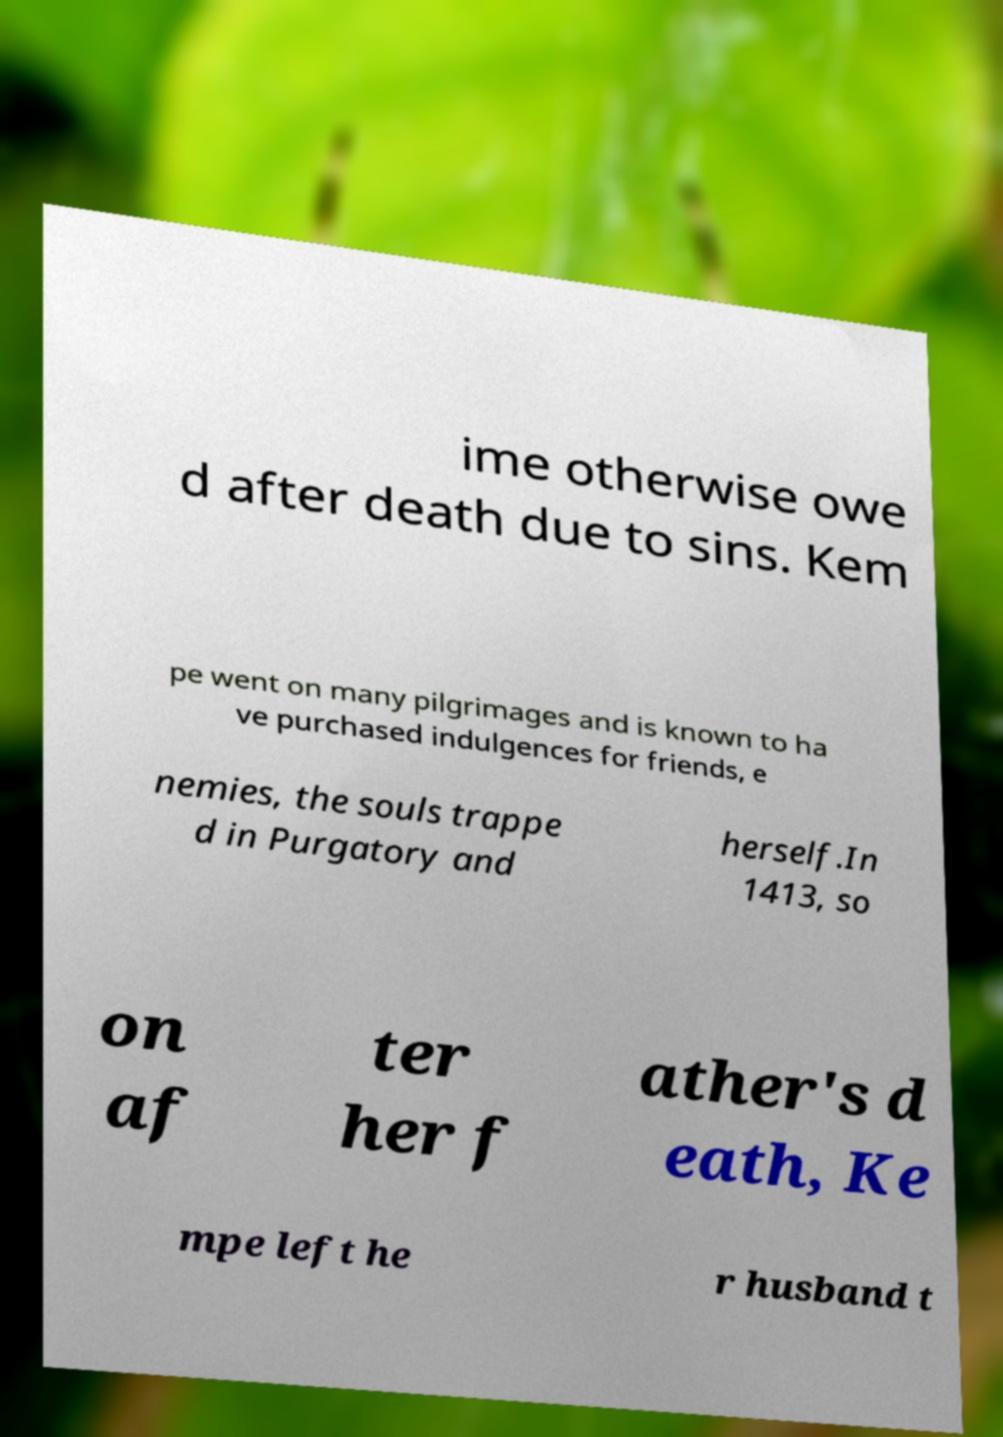For documentation purposes, I need the text within this image transcribed. Could you provide that? ime otherwise owe d after death due to sins. Kem pe went on many pilgrimages and is known to ha ve purchased indulgences for friends, e nemies, the souls trappe d in Purgatory and herself.In 1413, so on af ter her f ather's d eath, Ke mpe left he r husband t 